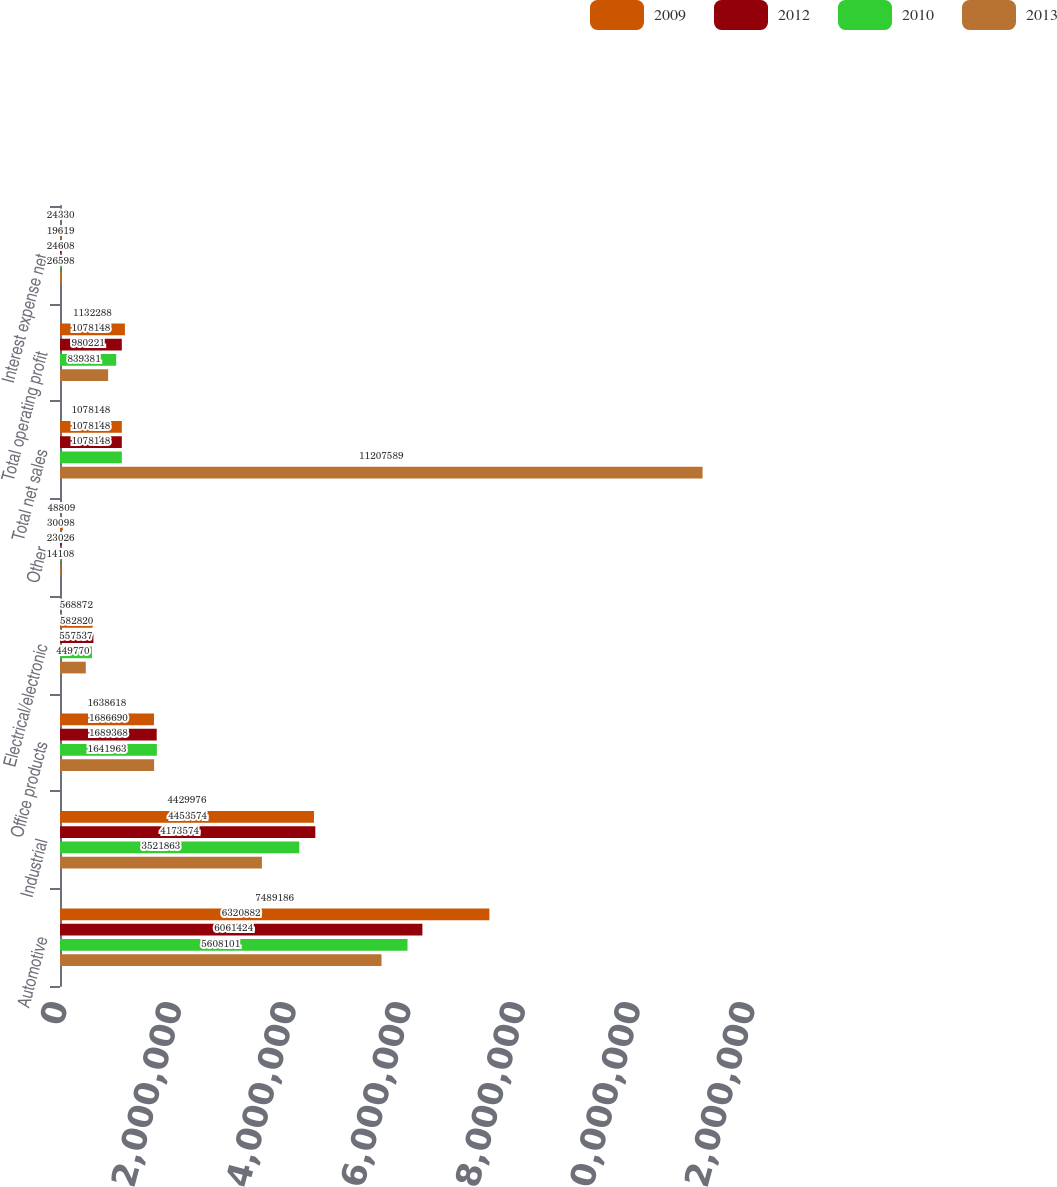<chart> <loc_0><loc_0><loc_500><loc_500><stacked_bar_chart><ecel><fcel>Automotive<fcel>Industrial<fcel>Office products<fcel>Electrical/electronic<fcel>Other<fcel>Total net sales<fcel>Total operating profit<fcel>Interest expense net<nl><fcel>2009<fcel>7.48919e+06<fcel>4.42998e+06<fcel>1.63862e+06<fcel>568872<fcel>48809<fcel>1.07815e+06<fcel>1.13229e+06<fcel>24330<nl><fcel>2012<fcel>6.32088e+06<fcel>4.45357e+06<fcel>1.68669e+06<fcel>582820<fcel>30098<fcel>1.07815e+06<fcel>1.07815e+06<fcel>19619<nl><fcel>2010<fcel>6.06142e+06<fcel>4.17357e+06<fcel>1.68937e+06<fcel>557537<fcel>23026<fcel>1.07815e+06<fcel>980221<fcel>24608<nl><fcel>2013<fcel>5.6081e+06<fcel>3.52186e+06<fcel>1.64196e+06<fcel>449770<fcel>14108<fcel>1.12076e+07<fcel>839381<fcel>26598<nl></chart> 